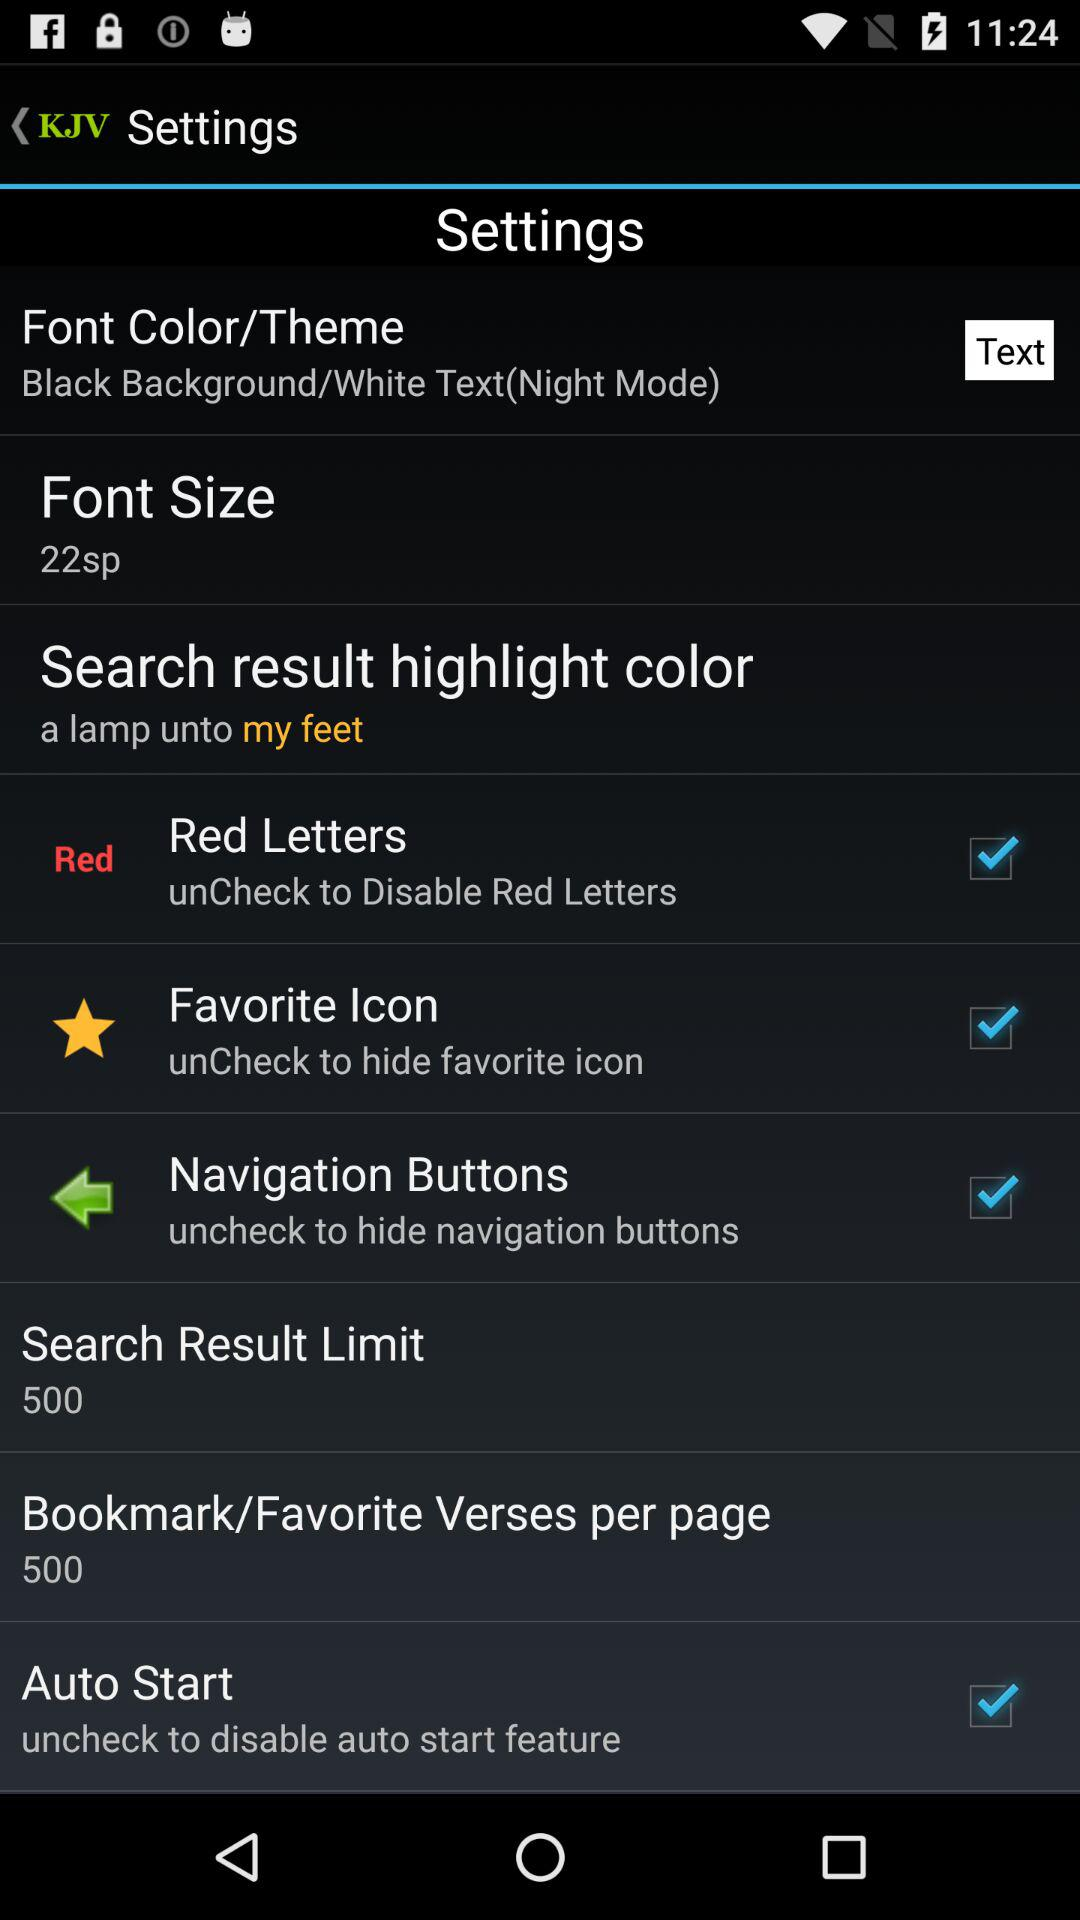What is the given font size? The given font size is 22 sp. 